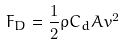<formula> <loc_0><loc_0><loc_500><loc_500>F _ { D } = \frac { 1 } { 2 } \rho C _ { d } A v ^ { 2 }</formula> 